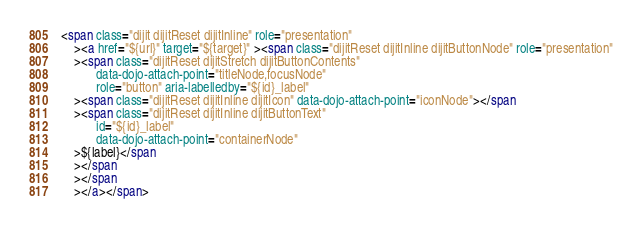Convert code to text. <code><loc_0><loc_0><loc_500><loc_500><_HTML_><span class="dijit dijitReset dijitInline" role="presentation"
	><a href="${url}" target="${target}" ><span class="dijitReset dijitInline dijitButtonNode" role="presentation"
	><span class="dijitReset dijitStretch dijitButtonContents"
		   data-dojo-attach-point="titleNode,focusNode"
		   role="button" aria-labelledby="${id}_label"
	><span class="dijitReset dijitInline dijitIcon" data-dojo-attach-point="iconNode"></span
	><span class="dijitReset dijitInline dijitButtonText"
		   id="${id}_label"
		   data-dojo-attach-point="containerNode"
	>${label}</span
	></span
	></span
	></a></span>
</code> 